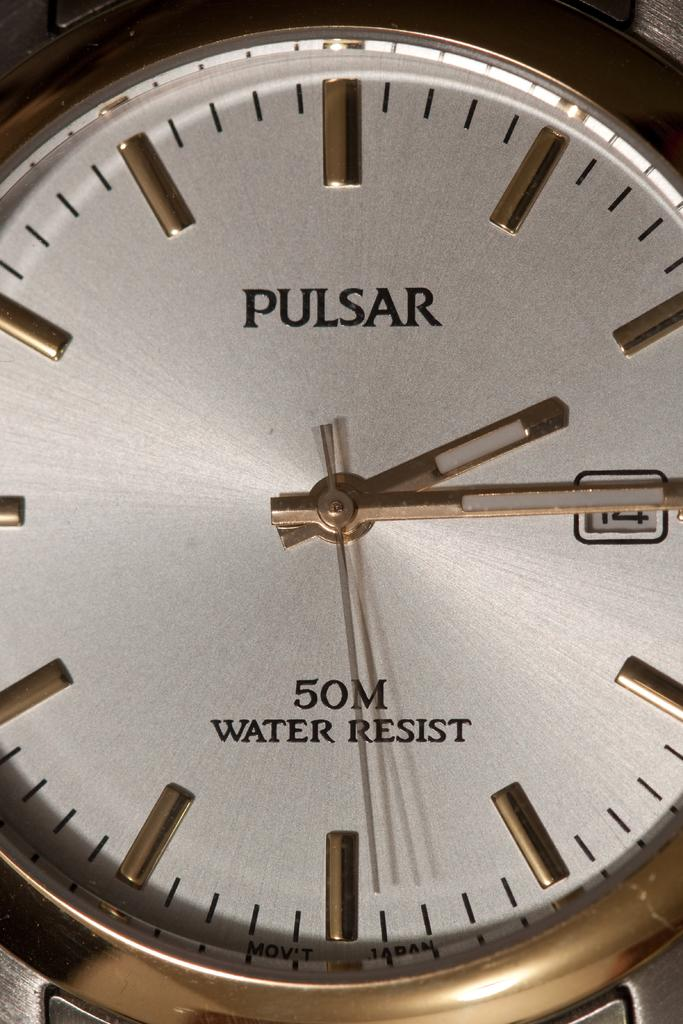Provide a one-sentence caption for the provided image. A gold and white Pulsar water resistant watch. 